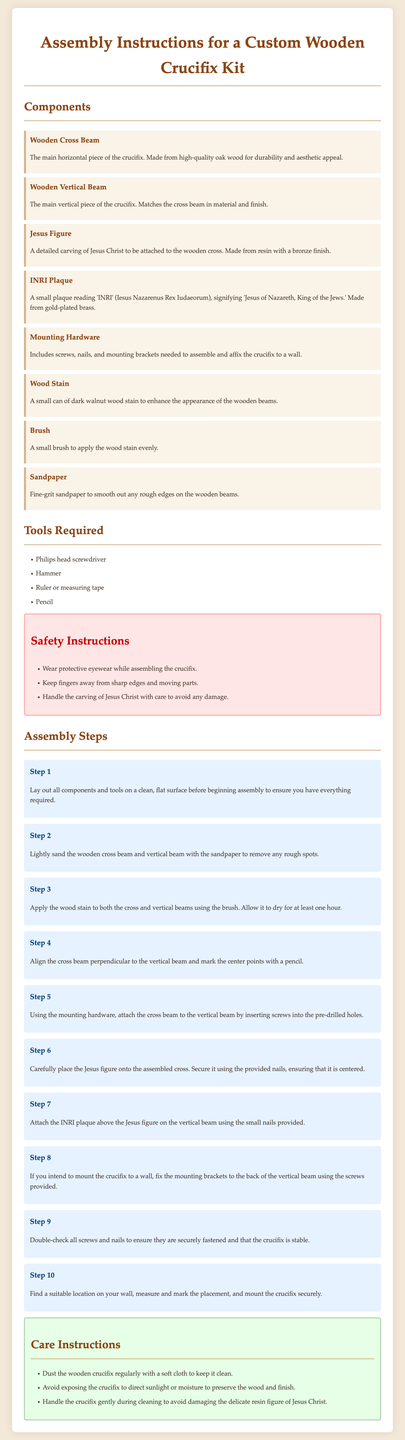What is the title of the document? The title is prominently displayed at the top of the document, stating the subject matter clearly.
Answer: Assembly Instructions for a Custom Wooden Crucifix Kit What material is the wooden cross beam made from? The components section specifies the material used for the wooden cross beam, emphasizing its quality.
Answer: High-quality oak wood What does the INRI plaque signify? The explanation of the INRI plaque describes its meaning and importance in relation to the crucifix.
Answer: Jesus of Nazareth, King of the Jews How many assembly steps are outlined in the instructions? By counting the numbered steps in the assembly section, you can determine the total number of steps provided for assembly.
Answer: Ten What tool is required to fix screws? The tools required section lists essential tools needed for the assembly process.
Answer: Philips head screwdriver What type of wood stain is included in the kit? The components section specifies the type of wood stain included, indicating its purpose.
Answer: Dark walnut wood stain What should you use to apply the wood stain? The components section mentions an item used for applying the wood stain, which helps ensure an even application.
Answer: Brush What is the purpose of the safety instructions? The safety section outlines critical precautions to take while assembling the crucifix, enhancing user safety during the process.
Answer: Ensure safety during assembly What should you do to care for the wooden crucifix? The care instructions emphasize maintenance actions required to preserve the crucifix's appearance and integrity.
Answer: Dust regularly with a soft cloth 